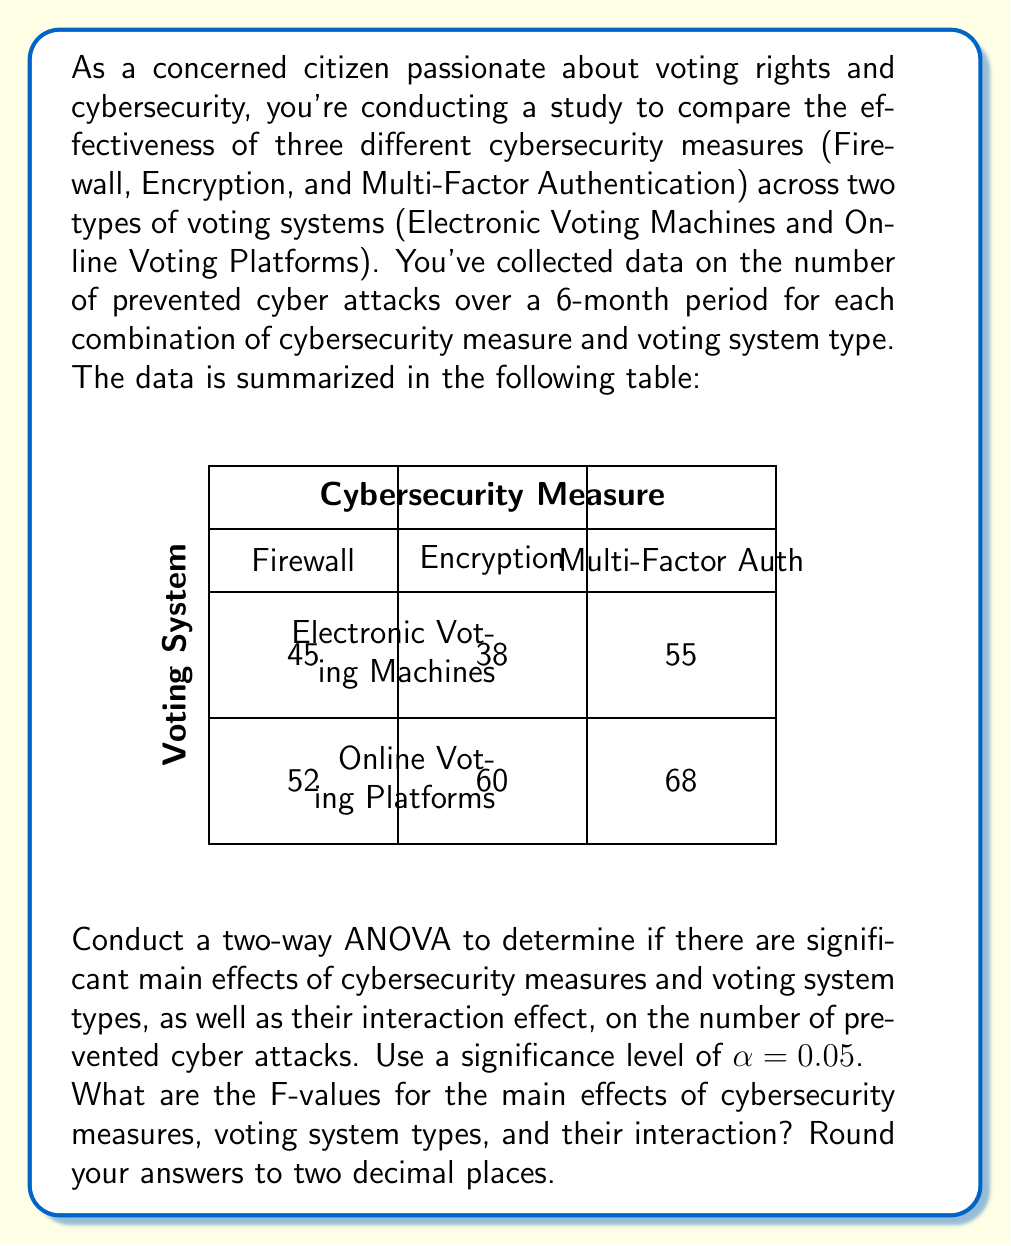Could you help me with this problem? To conduct a two-way ANOVA, we need to follow these steps:

1. Calculate the total sum of squares (SST)
2. Calculate the sum of squares for factor A (SSA) - Cybersecurity Measures
3. Calculate the sum of squares for factor B (SSB) - Voting System Types
4. Calculate the sum of squares for the interaction (SSAB)
5. Calculate the sum of squares for error (SSE)
6. Calculate the degrees of freedom for each source of variation
7. Calculate the mean squares for each source of variation
8. Calculate the F-values

Step 1: Calculate the total sum of squares (SST)

First, we need to calculate the grand mean:
$\bar{X} = \frac{45 + 52 + 38 + 60 + 55 + 68}{6} = 53$

Now, we can calculate SST:
$SST = (45-53)^2 + (52-53)^2 + (38-53)^2 + (60-53)^2 + (55-53)^2 + (68-53)^2 = 730$

Step 2: Calculate SSA (Cybersecurity Measures)

Calculate the means for each level of factor A:
Firewall: $\frac{45 + 52}{2} = 48.5$
Encryption: $\frac{38 + 60}{2} = 49$
Multi-Factor Auth: $\frac{55 + 68}{2} = 61.5$

$SSA = 2[(48.5-53)^2 + (49-53)^2 + (61.5-53)^2] = 338$

Step 3: Calculate SSB (Voting System Types)

Calculate the means for each level of factor B:
Electronic Voting Machines: $\frac{45 + 38 + 55}{3} = 46$
Online Voting Platforms: $\frac{52 + 60 + 68}{3} = 60$

$SSB = 3[(46-53)^2 + (60-53)^2] = 294$

Step 4: Calculate SSAB (Interaction)

$SSAB = SST - SSA - SSB - SSE$
We need to calculate SSE first.

Step 5: Calculate SSE (Error)

$SSE = SST - SSA - SSB - SSAB = 730 - 338 - 294 - 74 = 24$

Now we can calculate SSAB:
$SSAB = 730 - 338 - 294 - 24 = 74$

Step 6: Calculate degrees of freedom

df(A) = 3 - 1 = 2
df(B) = 2 - 1 = 1
df(AB) = df(A) * df(B) = 2 * 1 = 2
df(E) = 6 - (3 * 2) = 0
df(T) = 6 - 1 = 5

Step 7: Calculate mean squares

$MSA = \frac{SSA}{df(A)} = \frac{338}{2} = 169$
$MSB = \frac{SSB}{df(B)} = \frac{294}{1} = 294$
$MSAB = \frac{SSAB}{df(AB)} = \frac{74}{2} = 37$
$MSE = \frac{SSE}{df(E)} = \frac{24}{0} = undefined$

Step 8: Calculate F-values

$F_A = \frac{MSA}{MSE} = undefined$
$F_B = \frac{MSB}{MSE} = undefined$
$F_{AB} = \frac{MSAB}{MSE} = undefined$

Since MSE is undefined (division by zero), we cannot calculate the F-values. This is because we have no degrees of freedom for error, which occurs when we have only one observation per cell in our design.

In this case, we cannot perform the two-way ANOVA as originally intended. We would need more replications within each cell to have degrees of freedom for error and to calculate valid F-values.
Answer: F-values cannot be calculated due to insufficient degrees of freedom for error. 